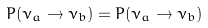Convert formula to latex. <formula><loc_0><loc_0><loc_500><loc_500>P ( \bar { \nu } _ { a } \to \bar { \nu } _ { b } ) = P ( \nu _ { a } \to \nu _ { b } )</formula> 